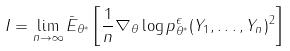Convert formula to latex. <formula><loc_0><loc_0><loc_500><loc_500>I = \lim _ { n \to \infty } \bar { E } _ { \theta ^ { \ast } } \left [ \frac { 1 } { n } \nabla _ { \theta } \log p _ { \theta ^ { \ast } } ^ { \epsilon } ( Y _ { 1 } , \dots , Y _ { n } ) ^ { 2 } \right ]</formula> 